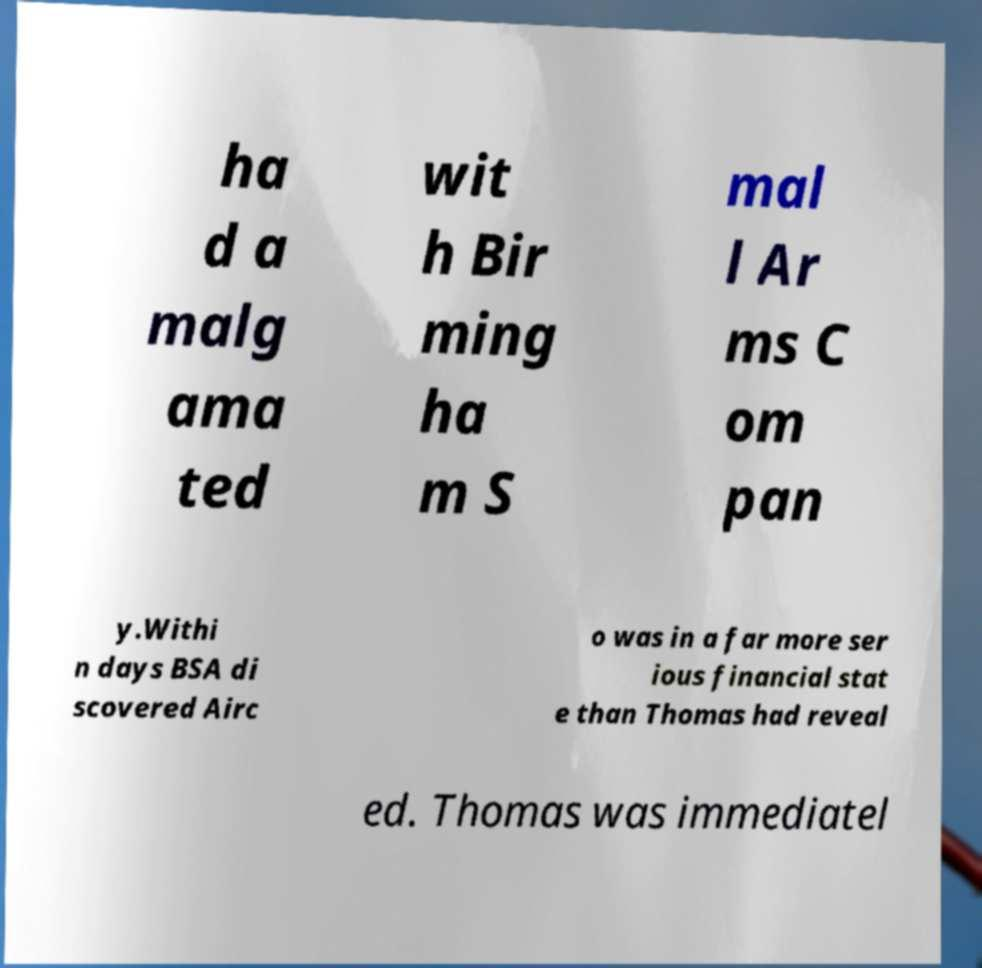Please read and relay the text visible in this image. What does it say? ha d a malg ama ted wit h Bir ming ha m S mal l Ar ms C om pan y.Withi n days BSA di scovered Airc o was in a far more ser ious financial stat e than Thomas had reveal ed. Thomas was immediatel 